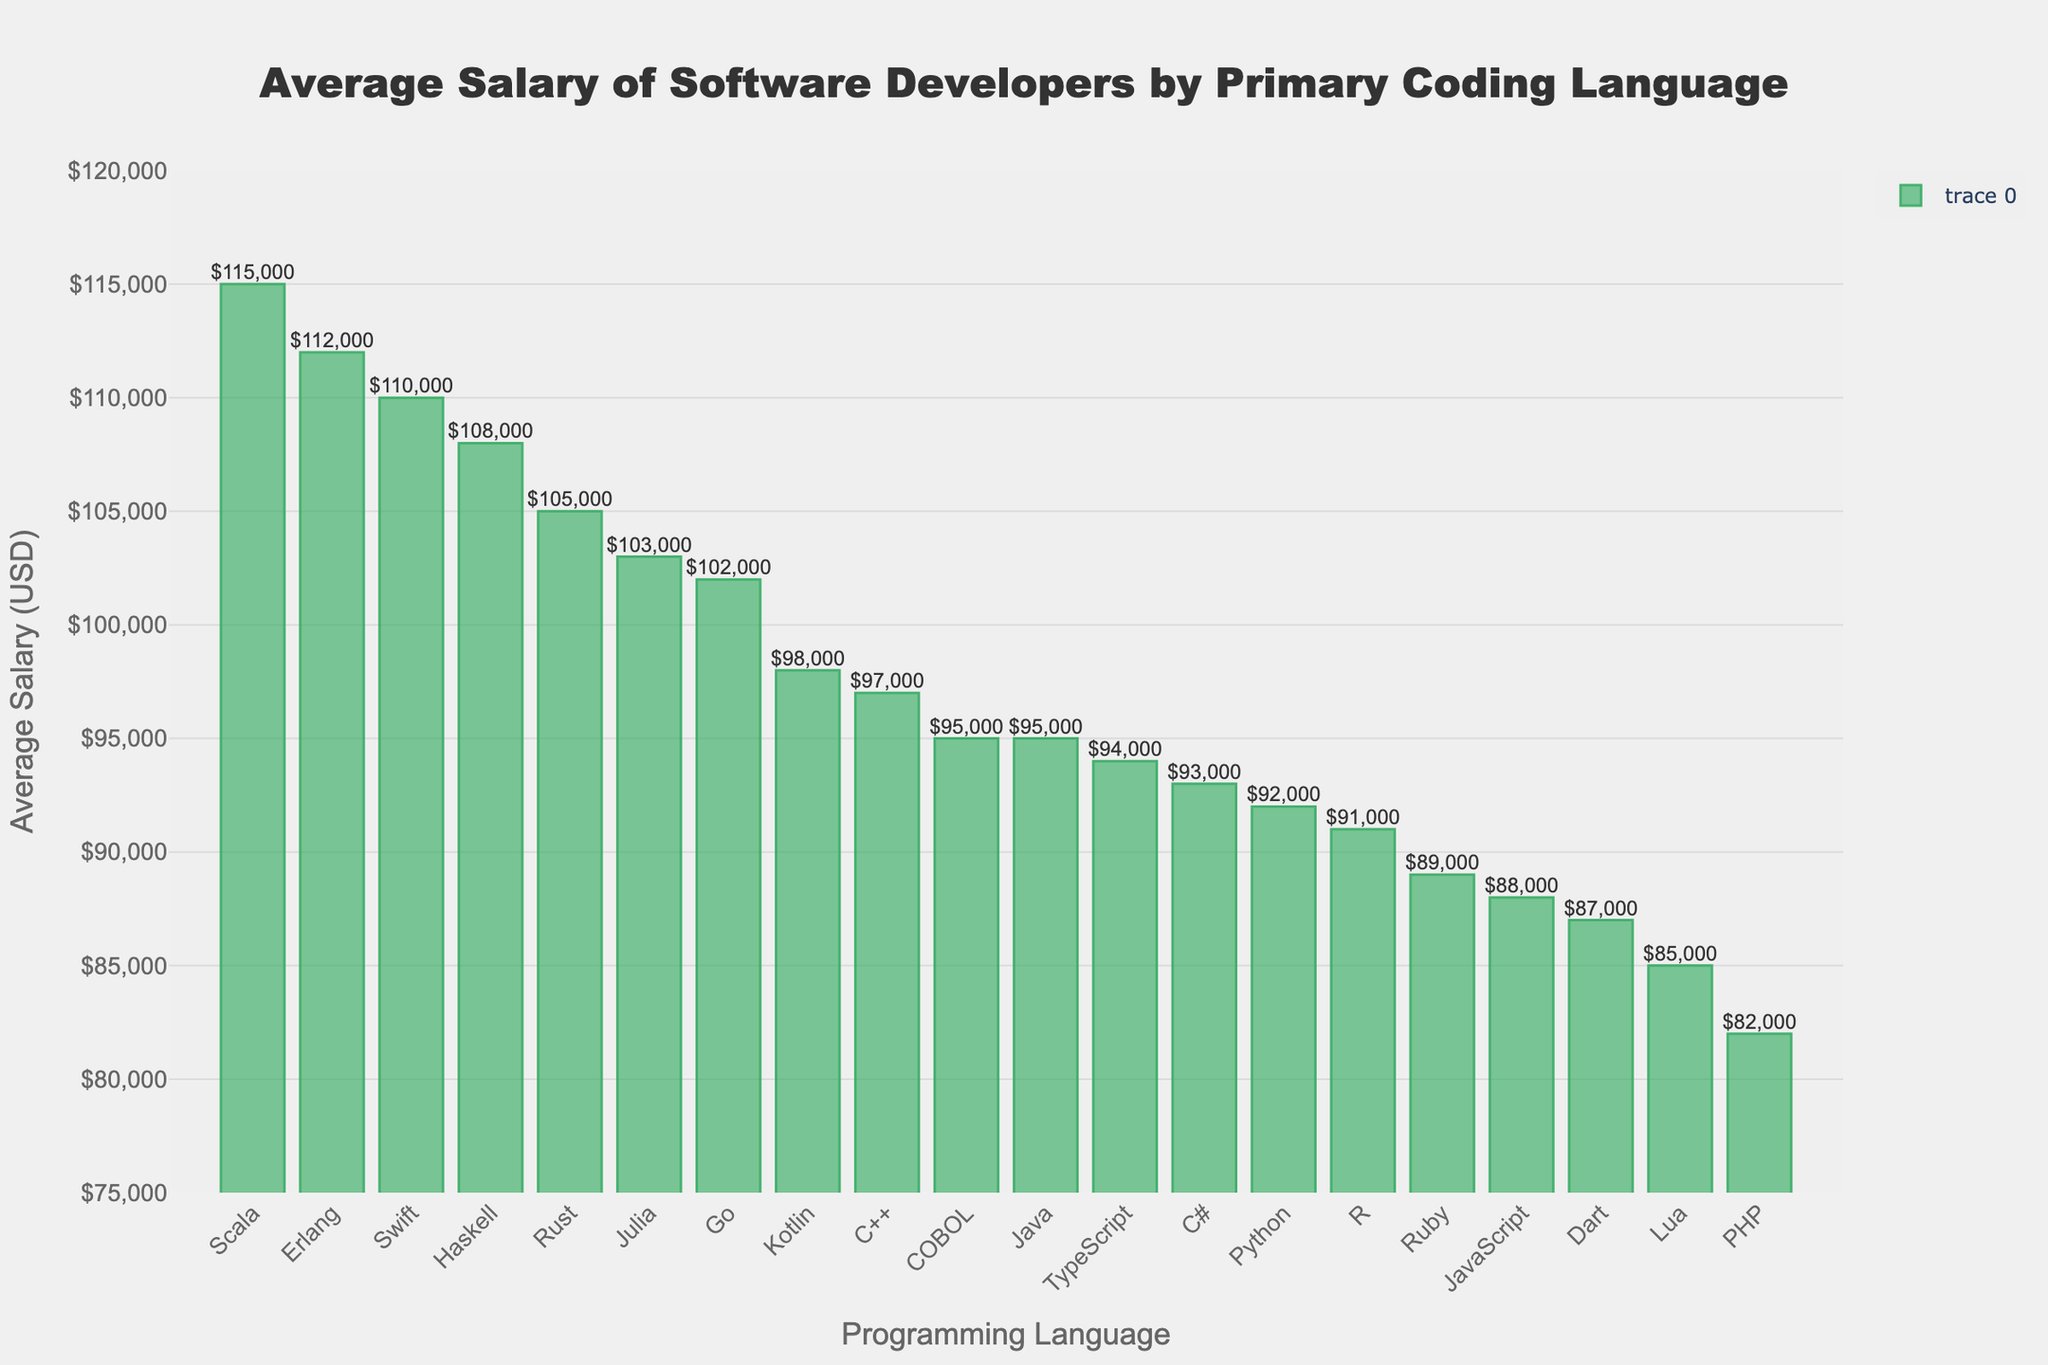Which programming language has the highest average salary? By looking at the tallest bar in the chart, we identify the language associated with this bar. The tallest bar represents Scala.
Answer: Scala What is the difference in average salary between the highest-paid and lowest-paid programming languages? The highest average salary is for Scala ($115,000) and the lowest is for PHP ($82,000). The difference is calculated by subtracting the lowest from the highest: $115,000 - $82,000.
Answer: $33,000 How many programming languages have an average salary above $100,000? By examining the bars that cross the $100,000 mark on the y-axis, we count them. The languages are Go, Rust, Swift, Kotlin, Scala, Haskell, and Erlang.
Answer: 7 Which programming language has a higher average salary, JavaScript or Java? By locating the bars for both JavaScript ($88,000) and Java ($95,000), we can compare their heights directly.
Answer: Java What is the combined average salary of developers who primarily code in Python and R? The average salaries are $92,000 for Python and $91,000 for R. Adding these gives: $92,000 + $91,000.
Answer: $183,000 Which programming language has an average salary closest to $90,000? Looking for the bars that are nearest to the $90,000 mark on the y-axis, we find that Ruby closely matches it with an average salary of $89,000.
Answer: Ruby Are there more programming languages with average salaries above or below $90,000? Count the number of programming languages above $90,000 and below $90,000. Above $90,000 are Python, Java, C++, C#, Go, Rust, Swift, Kotlin, TypeScript, Scala, Haskell, Erlang. Below $90,000 are JavaScript, Ruby, PHP, Dart, Lua, COBOL.
Answer: More above $90,000 Which two languages have the closest average salary? By comparing the bars closely, we find that Python ($92,000) and R ($91,000) have the smallest difference.
Answer: Python and R What is the average salary range of the programming languages displayed? The range is calculated by subtracting the lowest average salary ($82,000 for PHP) from the highest average salary ($115,000 for Scala): $115,000 - $82,000.
Answer: $33,000 How does the average salary of Dart developers compare to that of Erlang developers? Dart's average salary is $87,000 and Erlang's is $112,000. Dart's salary is less, and the difference is calculated by subtracting $87,000 from $112,000.
Answer: $25,000 less 